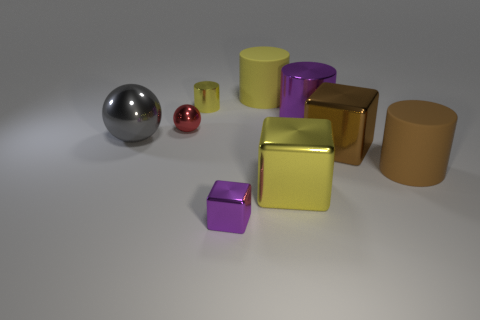Add 1 small red matte spheres. How many objects exist? 10 Subtract all cylinders. How many objects are left? 5 Subtract all cylinders. Subtract all small purple shiny objects. How many objects are left? 4 Add 5 large brown matte things. How many large brown matte things are left? 6 Add 5 small blue shiny cylinders. How many small blue shiny cylinders exist? 5 Subtract 0 blue spheres. How many objects are left? 9 